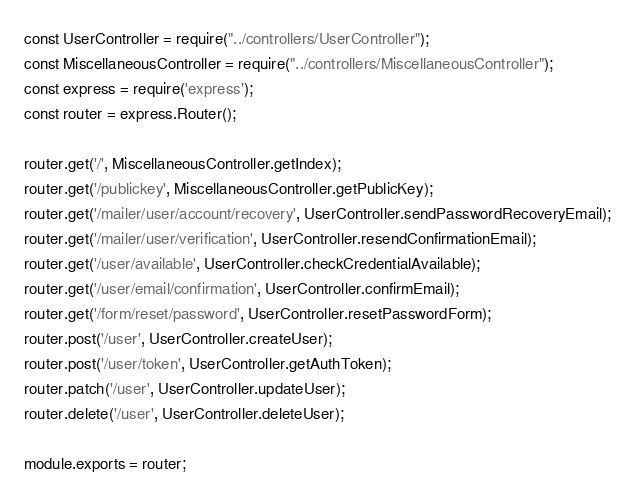Convert code to text. <code><loc_0><loc_0><loc_500><loc_500><_JavaScript_>const UserController = require("../controllers/UserController");
const MiscellaneousController = require("../controllers/MiscellaneousController");
const express = require('express');
const router = express.Router();

router.get('/', MiscellaneousController.getIndex);
router.get('/publickey', MiscellaneousController.getPublicKey);
router.get('/mailer/user/account/recovery', UserController.sendPasswordRecoveryEmail);
router.get('/mailer/user/verification', UserController.resendConfirmationEmail);
router.get('/user/available', UserController.checkCredentialAvailable);
router.get('/user/email/confirmation', UserController.confirmEmail);
router.get('/form/reset/password', UserController.resetPasswordForm);
router.post('/user', UserController.createUser);
router.post('/user/token', UserController.getAuthToken);
router.patch('/user', UserController.updateUser);
router.delete('/user', UserController.deleteUser);

module.exports = router;</code> 